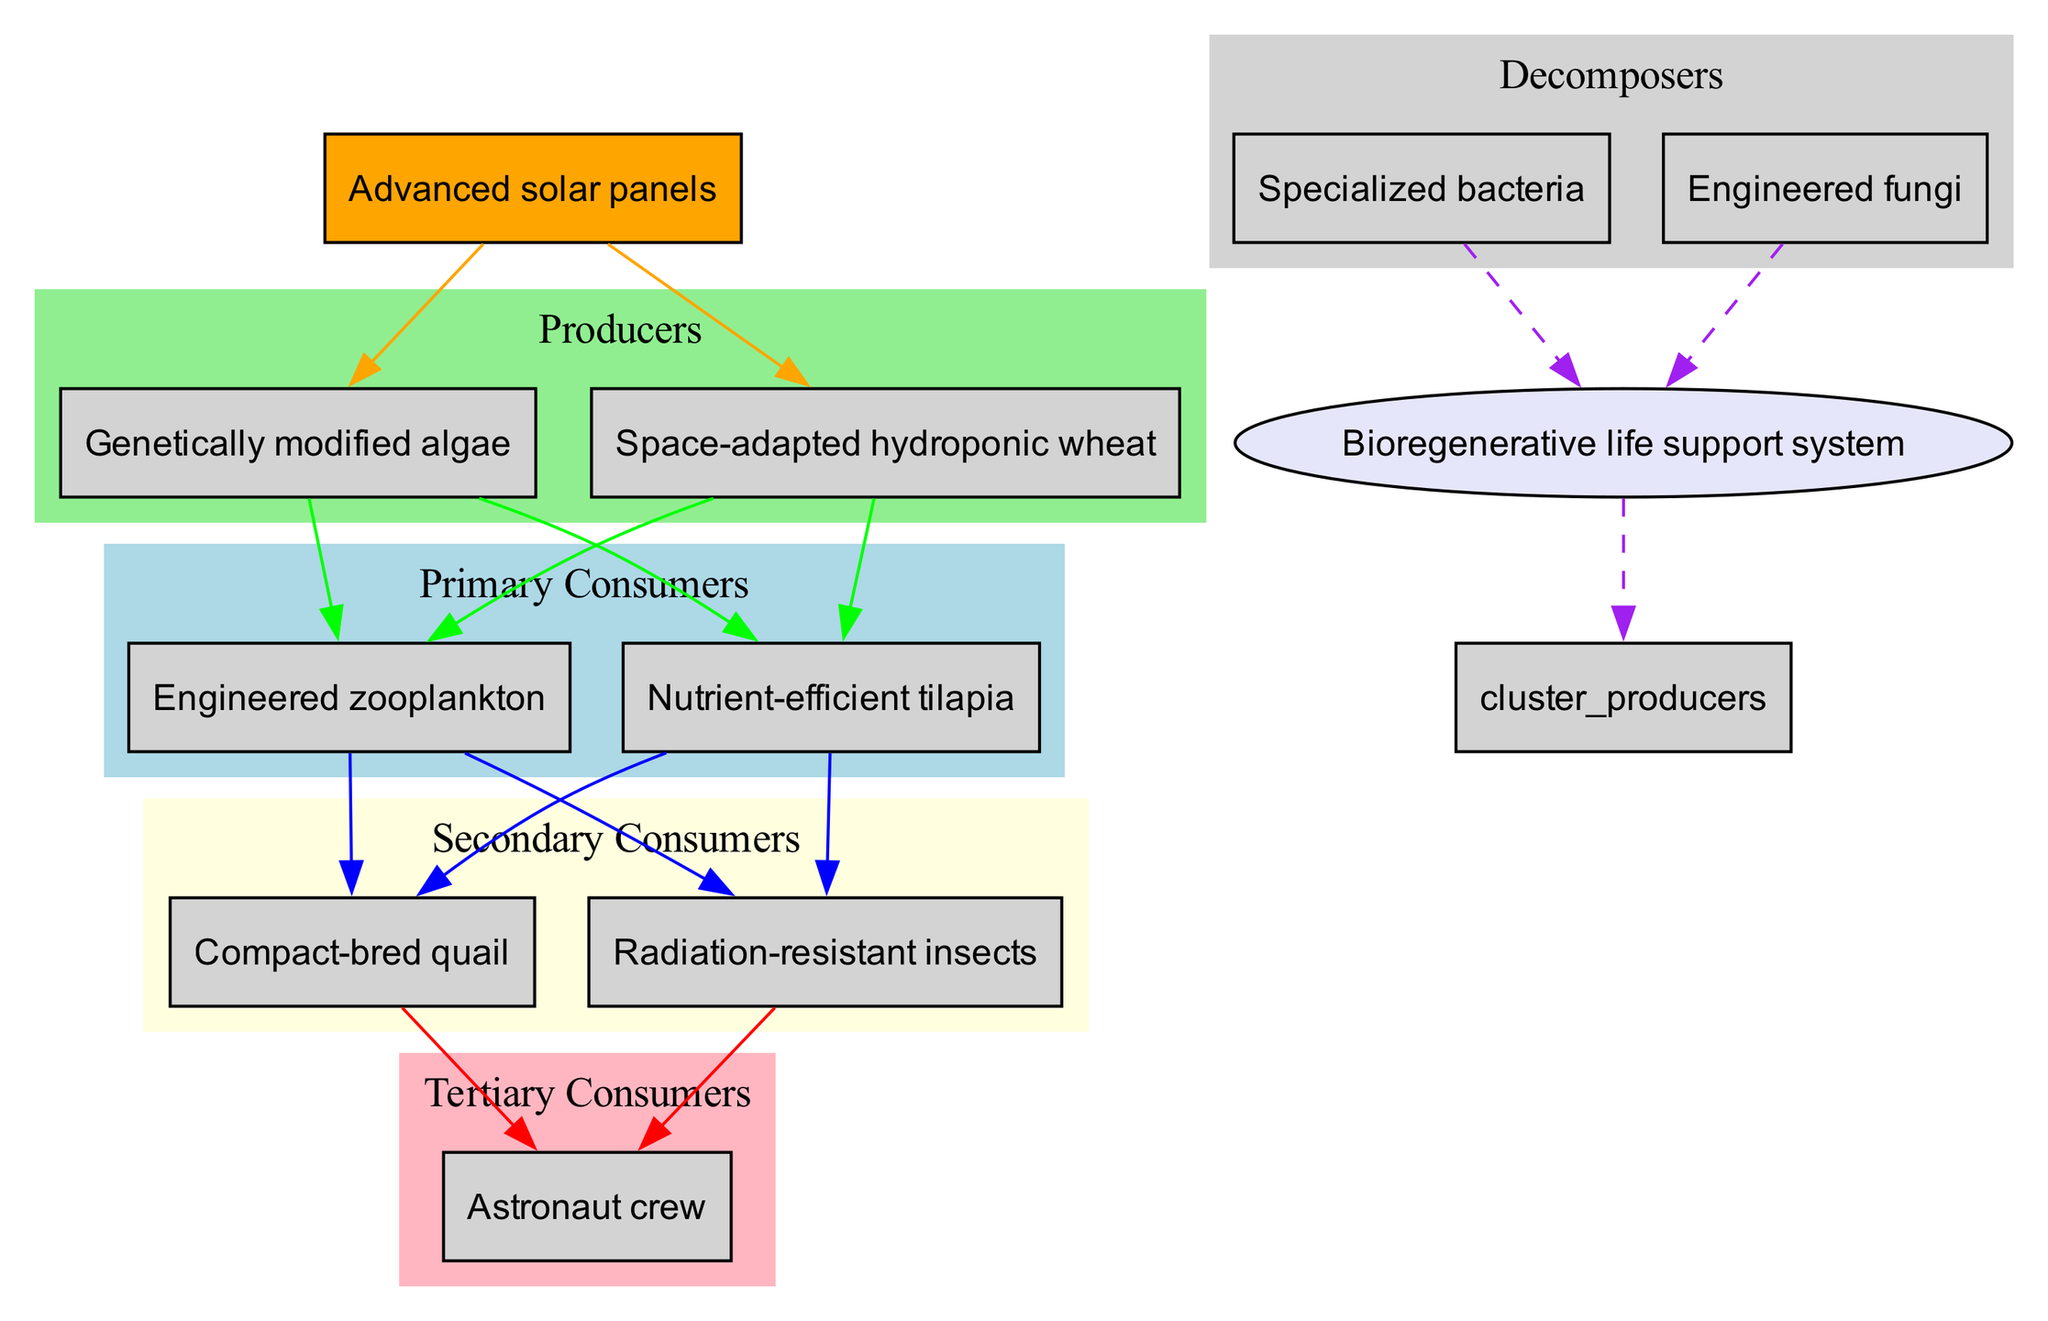What are the primary consumers in the ecosystem? The primary consumers in the diagram are listed as engineered zooplankton and nutrient-efficient tilapia.
Answer: engineered zooplankton, nutrient-efficient tilapia How many producers are there in the diagram? The diagram shows two producers: genetically modified algae and space-adapted hydroponic wheat. Thus, the count is 2.
Answer: 2 Which trophic level directly consumes genetically modified algae? The engineered zooplankton directly consumes genetically modified algae as they are primary consumers that feed on producers.
Answer: engineered zooplankton What types of decomposers are included in the ecosystem? The diagram indicates the decomposers are specialized bacteria and engineered fungi.
Answer: specialized bacteria, engineered fungi Who are the tertiary consumers in the ecosystem? The only tertiary consumer depicted in the diagram is the astronaut crew, which is the top consumer level.
Answer: astronaut crew Which node connects all decomposers in the diagram? All decomposers are linked to the nutrient recycling node, which is indicated as a bioregenerative life support system.
Answer: nutrient recycling How many edges connect the secondary consumers to the tertiary consumers? Each secondary consumer, compact-bred quail and radiation-resistant insects, is connected to the sole tertiary consumer (astronaut crew) via two edges, hence the total is 2.
Answer: 2 What relationship does the advanced solar panels have with the producers? The advanced solar panels serve as the energy source that provides energy to the producers illustrated in the diagram, which is represented by edges pointing from the energy source to the producers.
Answer: energy source Which trophic level is directly influenced by the nutrient recycling system? The nutrient recycling system directly influences the producer level by providing regenerated nutrients necessary for their growth and sustainability.
Answer: producers 